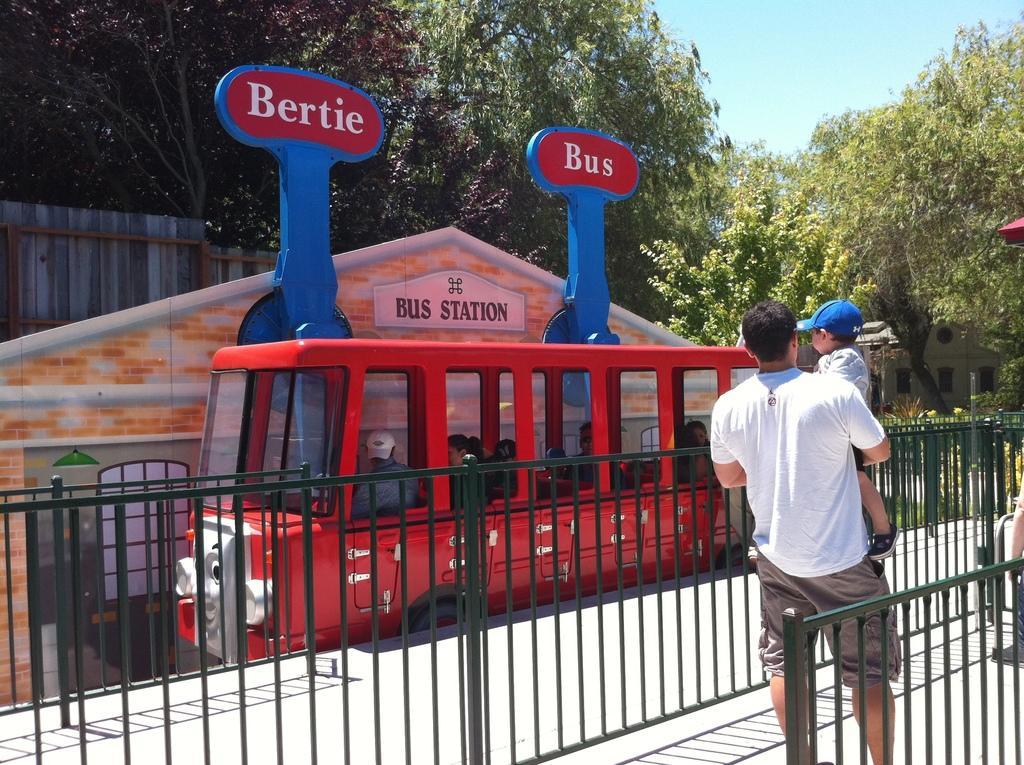Describe this image in one or two sentences. This is the picture of a person who is carrying a child and to the side there is a red color bus, in the bus there are so many people and some trees and plants around. 